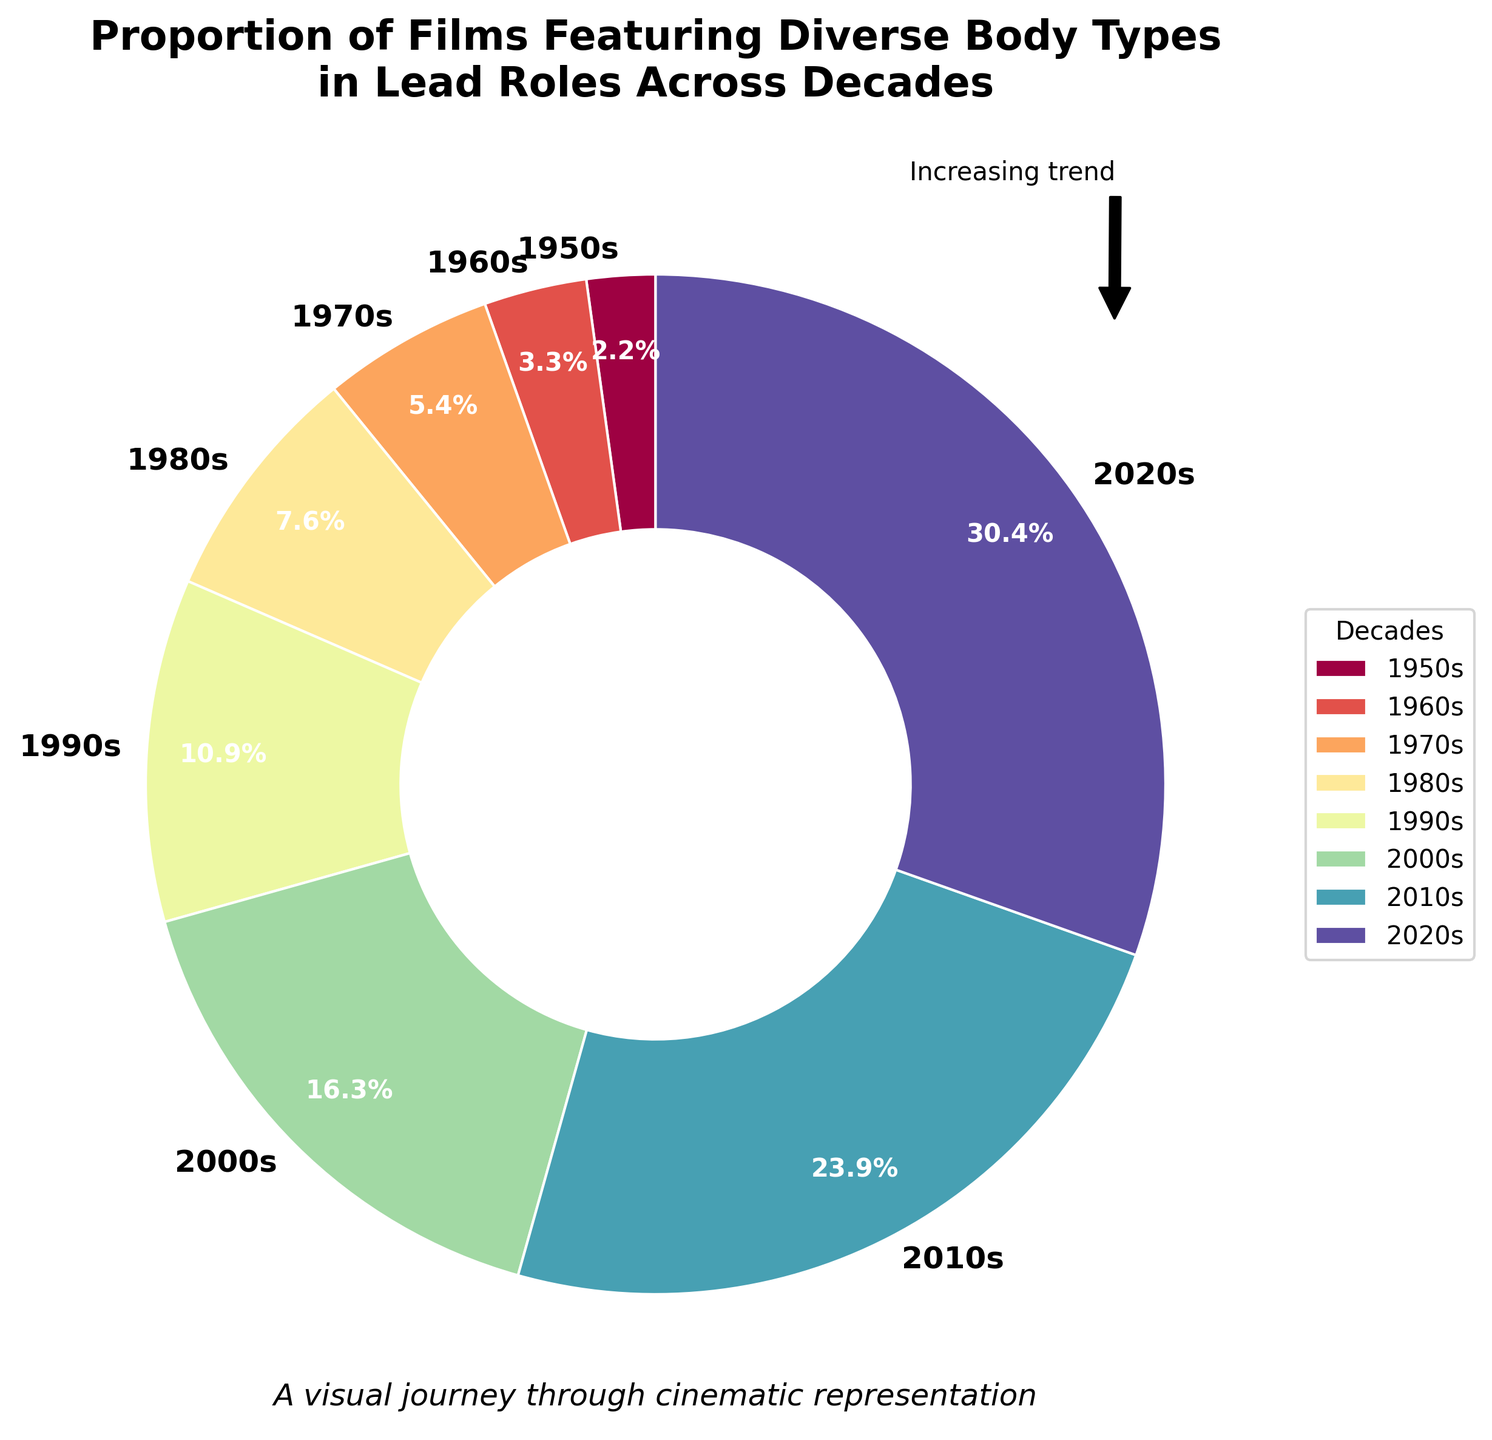What is the percentage of films featuring diverse body types in the lead roles in the 2020s? Look at the segment labeled "2020s" in the pie chart. The percentage should be marked on or near the segment.
Answer: 28% How many percentages higher is the 2010s segment compared to the 1950s segment? Compare the percentage of the 2010s (22%) to the 1950s (2%) by subtracting the latter from the former: 22% - 2% = 20%.
Answer: 20% Which decade had a lower percentage of films featuring diverse body types in lead roles, the 1960s or the 1980s? Compare the percentages for the two decades: 1960s (3%) and 1980s (7%). The 1960s has a lower percentage.
Answer: 1960s What is the total percentage of films featuring diverse body types in lead roles from the 1950s to the 1980s? Add the percentages for the 1950s (2%), 1960s (3%), 1970s (5%), and 1980s (7%): 2% + 3% + 5% + 7% = 17%.
Answer: 17% Which decade shows the highest increase in percentage from the previous decade? Calculate the percentage increase for each decade: 
- 1960s: 3% - 2% = 1%
- 1970s: 5% - 3% = 2%
- 1980s: 7% - 5% = 2%
- 1990s: 10% - 7% = 3%
- 2000s: 15% - 10% = 5%
- 2010s: 22% - 15% = 7%
- 2020s: 28% - 22% = 6%
The highest increase is from the 2000s to the 2010s (7%).
Answer: 2010s Which colors are used to represent the different decades in the pie chart? Identify the color scheme applied in the pie chart segments. Start from the smallest to the largest segment to list them accordingly.
Answer: - 1950s: Purple/pink
- 1960s: Magenta
- 1970s: Red
- 1980s: Orange
- 1990s: Yellow
- 2000s: Green
- 2010s: Cyan
- 2020s: Blue What is the average percentage of films featuring diverse body types in lead roles over all the decades shown? Add the percentages for all the decades and divide by the number of decades: (2% + 3% + 5% + 7% + 10% + 15% + 22% + 28%) / 8 = 92% / 8 = 11.5%.
Answer: 11.5% Between which consecutive decades did the proportion of films featuring diverse body types in lead roles double? Check the percentages to see where a decade is at least twice as large as the prior one:
- No doubling between 1950s and 1960s (3% is not 2*2%).
- 1960s to 1970s (5% is not 2*3%).
- 1970s to 1980s (7% is not 2*5%).
- 1980s to 1990s (10% is not 2*7%).
- 1990s to 2000s (15% is not 2*10%).
Indicating no exact doubling occurs.
Answer: None What annotation is used in the plot to emphasize a trend? Look at the text or symbols added to the pie chart segment, aside from the labels and percentages. Identify the specific annotation used.
Answer: "Increasing trend" with an arrow pointing from the 2020s to the 2010s 